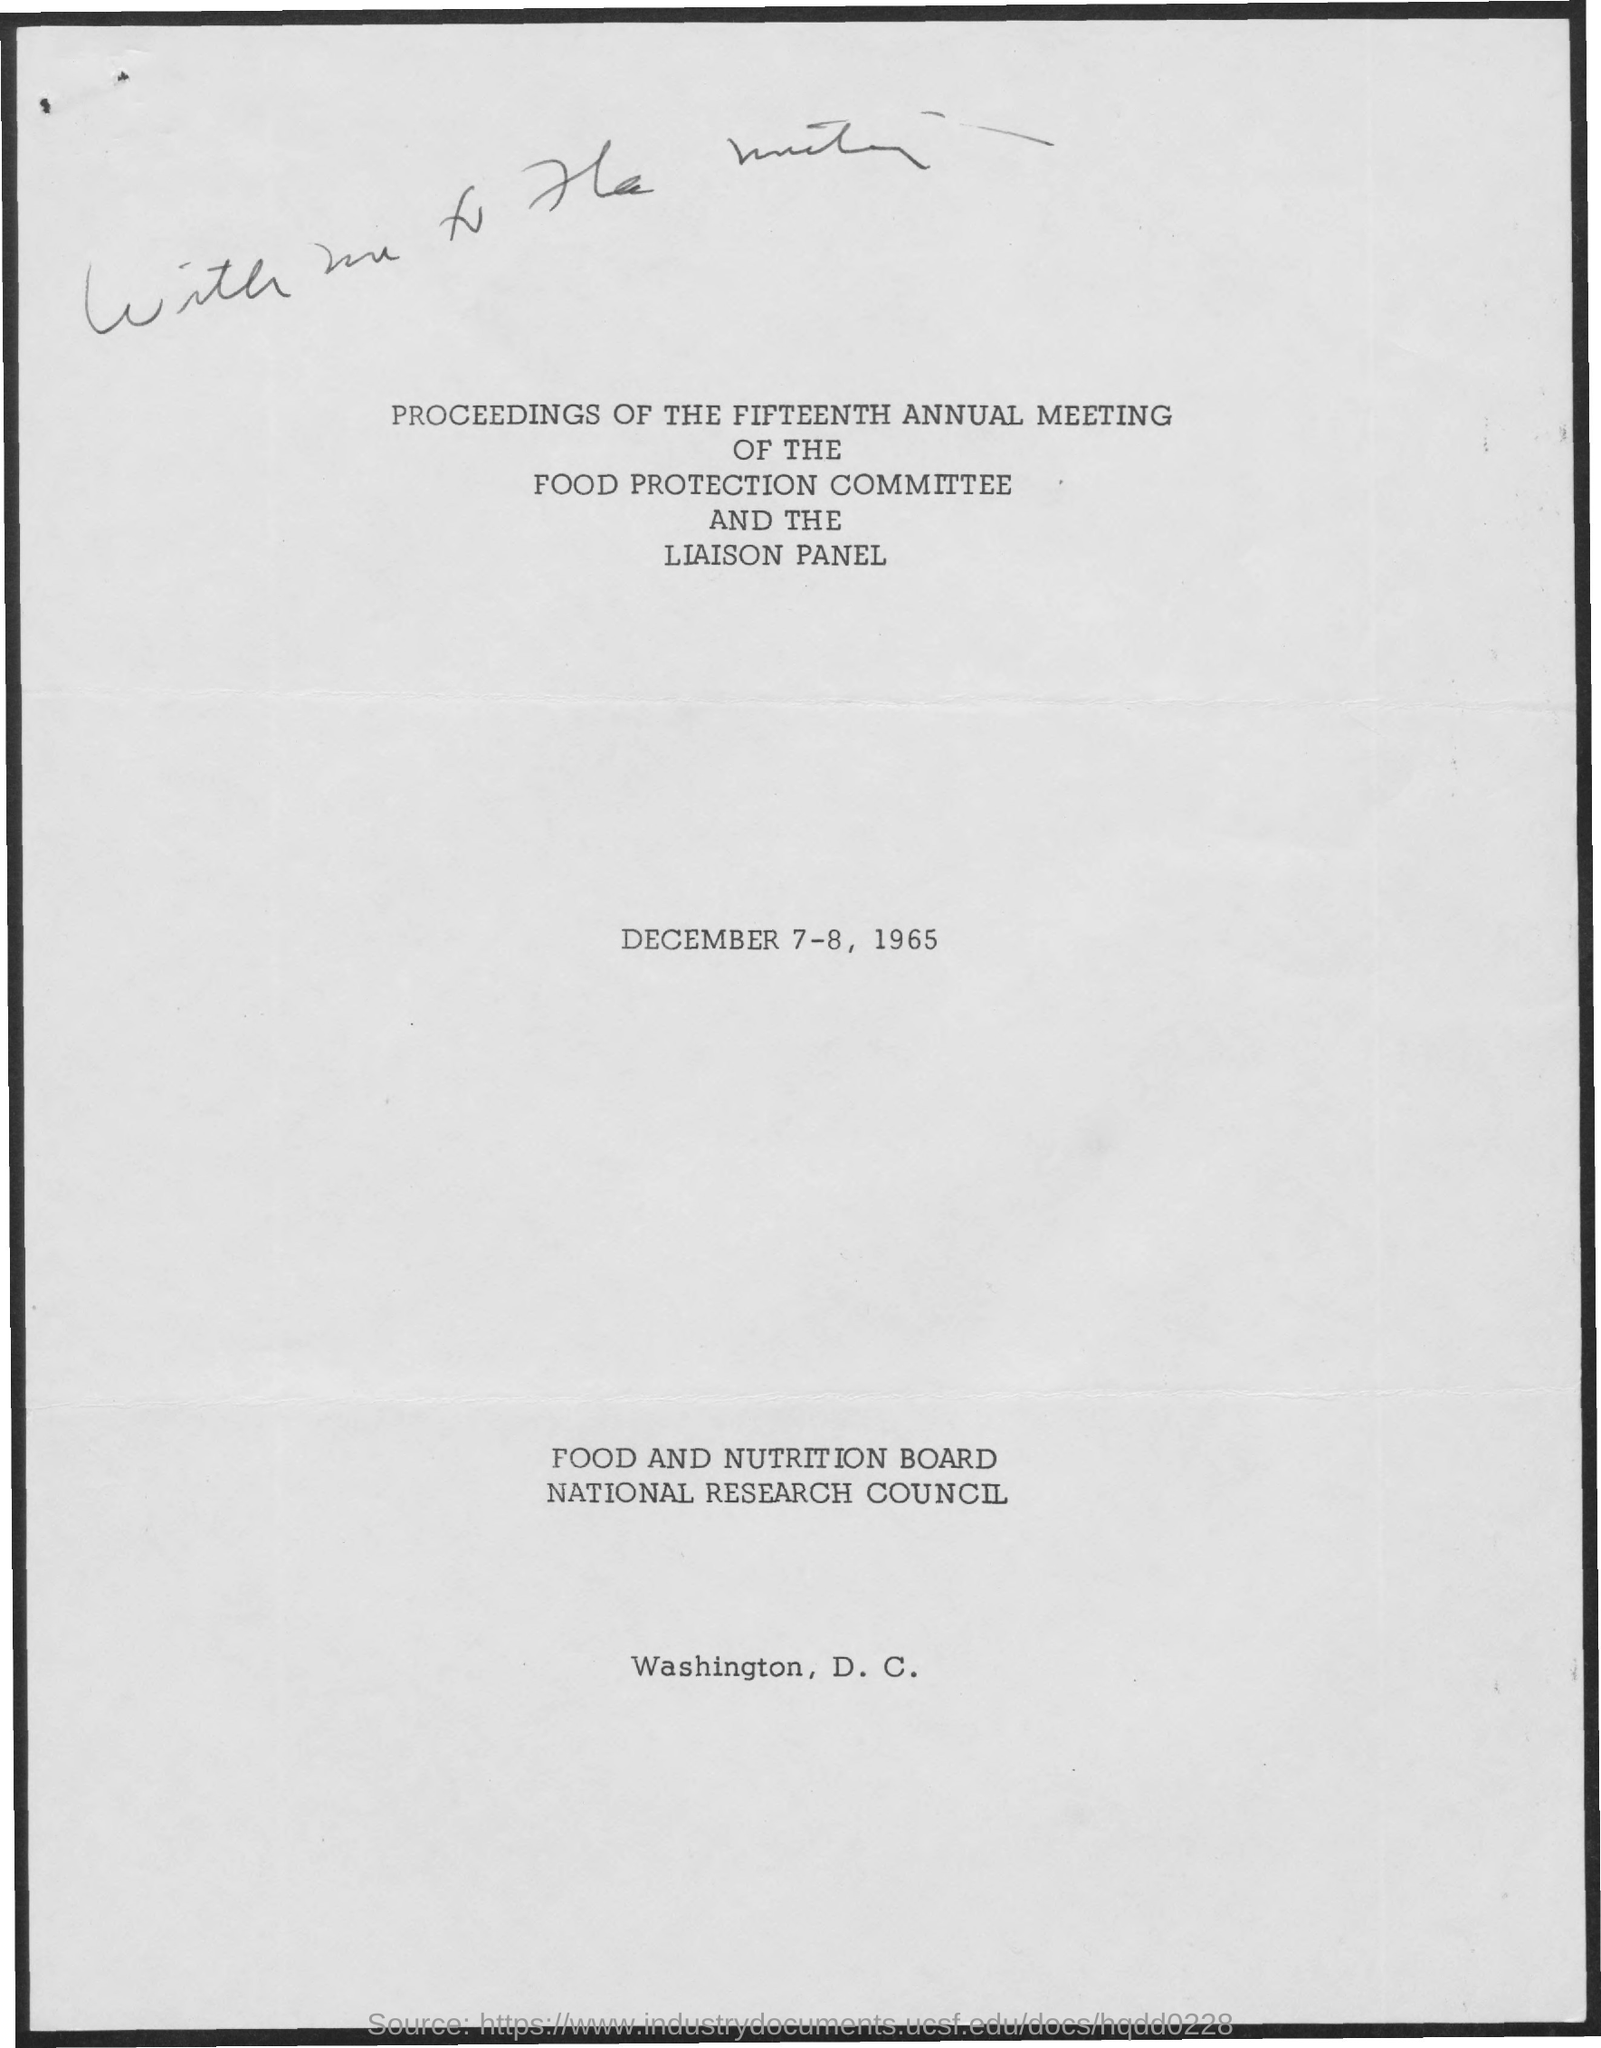Outline some significant characteristics in this image. The date mentioned in the document is December 7-8, 1965. 